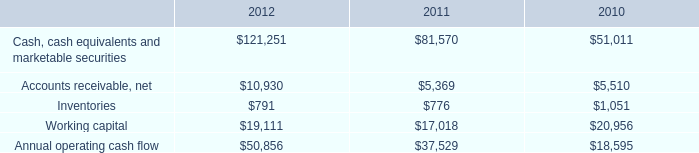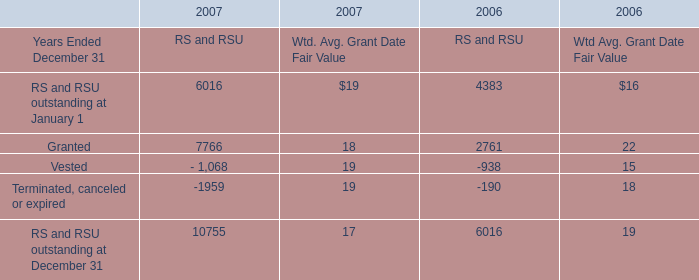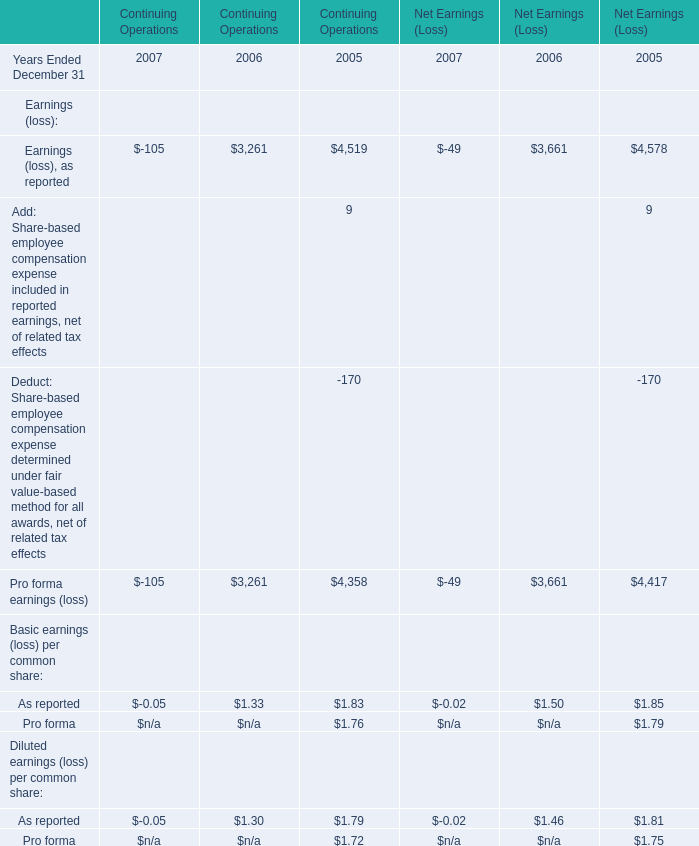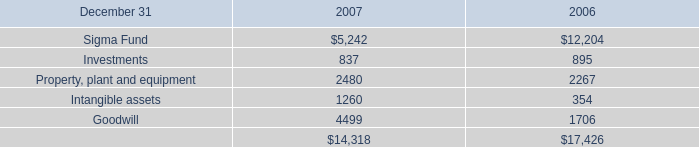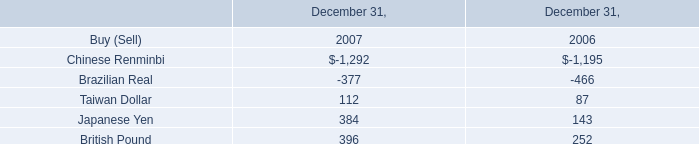What do all element sum up without those element smaller than 0 in 2007 for RS and RSU? 
Computations: ((6016 + 7766) + 10755)
Answer: 24537.0. 